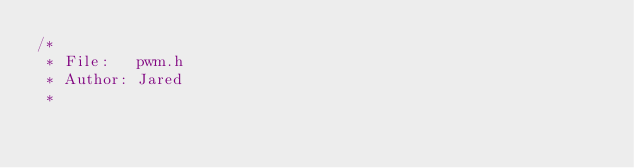Convert code to text. <code><loc_0><loc_0><loc_500><loc_500><_C_>/* 
 * File:   pwm.h
 * Author: Jared
 *</code> 